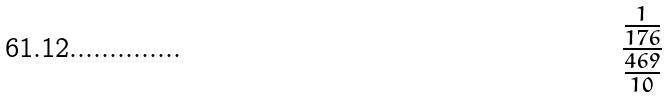Convert formula to latex. <formula><loc_0><loc_0><loc_500><loc_500>\frac { \frac { 1 } { 1 7 6 } } { \frac { 4 6 9 } { 1 0 } }</formula> 